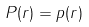<formula> <loc_0><loc_0><loc_500><loc_500>P ( r ) = p ( r )</formula> 